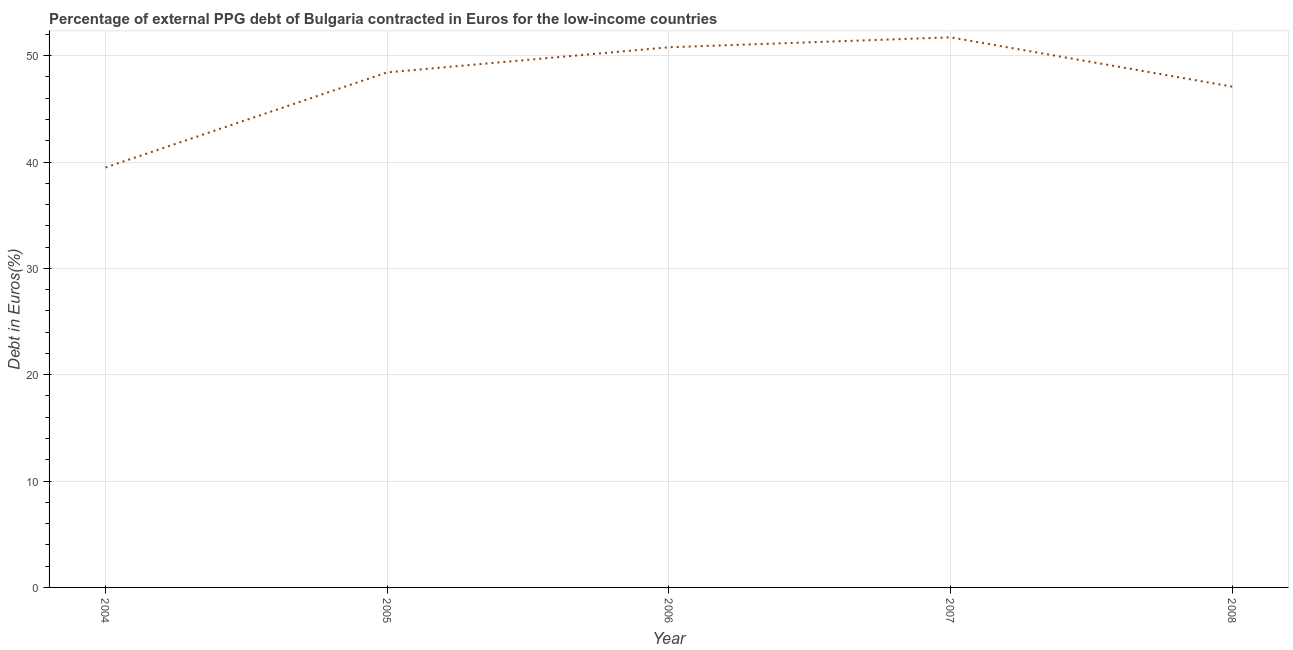What is the currency composition of ppg debt in 2006?
Offer a very short reply. 50.79. Across all years, what is the maximum currency composition of ppg debt?
Keep it short and to the point. 51.72. Across all years, what is the minimum currency composition of ppg debt?
Your response must be concise. 39.48. What is the sum of the currency composition of ppg debt?
Keep it short and to the point. 237.52. What is the difference between the currency composition of ppg debt in 2005 and 2008?
Ensure brevity in your answer.  1.34. What is the average currency composition of ppg debt per year?
Ensure brevity in your answer.  47.5. What is the median currency composition of ppg debt?
Give a very brief answer. 48.43. In how many years, is the currency composition of ppg debt greater than 40 %?
Your answer should be very brief. 4. What is the ratio of the currency composition of ppg debt in 2006 to that in 2008?
Give a very brief answer. 1.08. What is the difference between the highest and the second highest currency composition of ppg debt?
Provide a succinct answer. 0.93. Is the sum of the currency composition of ppg debt in 2006 and 2007 greater than the maximum currency composition of ppg debt across all years?
Give a very brief answer. Yes. What is the difference between the highest and the lowest currency composition of ppg debt?
Provide a succinct answer. 12.24. Does the currency composition of ppg debt monotonically increase over the years?
Offer a terse response. No. How many lines are there?
Provide a succinct answer. 1. How many years are there in the graph?
Provide a succinct answer. 5. Does the graph contain grids?
Keep it short and to the point. Yes. What is the title of the graph?
Your response must be concise. Percentage of external PPG debt of Bulgaria contracted in Euros for the low-income countries. What is the label or title of the X-axis?
Keep it short and to the point. Year. What is the label or title of the Y-axis?
Your response must be concise. Debt in Euros(%). What is the Debt in Euros(%) of 2004?
Ensure brevity in your answer.  39.48. What is the Debt in Euros(%) in 2005?
Ensure brevity in your answer.  48.43. What is the Debt in Euros(%) of 2006?
Your answer should be compact. 50.79. What is the Debt in Euros(%) in 2007?
Give a very brief answer. 51.72. What is the Debt in Euros(%) of 2008?
Offer a very short reply. 47.09. What is the difference between the Debt in Euros(%) in 2004 and 2005?
Make the answer very short. -8.94. What is the difference between the Debt in Euros(%) in 2004 and 2006?
Offer a terse response. -11.31. What is the difference between the Debt in Euros(%) in 2004 and 2007?
Provide a short and direct response. -12.24. What is the difference between the Debt in Euros(%) in 2004 and 2008?
Offer a very short reply. -7.61. What is the difference between the Debt in Euros(%) in 2005 and 2006?
Provide a short and direct response. -2.36. What is the difference between the Debt in Euros(%) in 2005 and 2007?
Offer a very short reply. -3.3. What is the difference between the Debt in Euros(%) in 2005 and 2008?
Provide a short and direct response. 1.34. What is the difference between the Debt in Euros(%) in 2006 and 2007?
Give a very brief answer. -0.93. What is the difference between the Debt in Euros(%) in 2006 and 2008?
Keep it short and to the point. 3.7. What is the difference between the Debt in Euros(%) in 2007 and 2008?
Ensure brevity in your answer.  4.63. What is the ratio of the Debt in Euros(%) in 2004 to that in 2005?
Offer a terse response. 0.81. What is the ratio of the Debt in Euros(%) in 2004 to that in 2006?
Offer a very short reply. 0.78. What is the ratio of the Debt in Euros(%) in 2004 to that in 2007?
Provide a succinct answer. 0.76. What is the ratio of the Debt in Euros(%) in 2004 to that in 2008?
Ensure brevity in your answer.  0.84. What is the ratio of the Debt in Euros(%) in 2005 to that in 2006?
Your answer should be very brief. 0.95. What is the ratio of the Debt in Euros(%) in 2005 to that in 2007?
Ensure brevity in your answer.  0.94. What is the ratio of the Debt in Euros(%) in 2005 to that in 2008?
Keep it short and to the point. 1.03. What is the ratio of the Debt in Euros(%) in 2006 to that in 2008?
Offer a terse response. 1.08. What is the ratio of the Debt in Euros(%) in 2007 to that in 2008?
Provide a succinct answer. 1.1. 